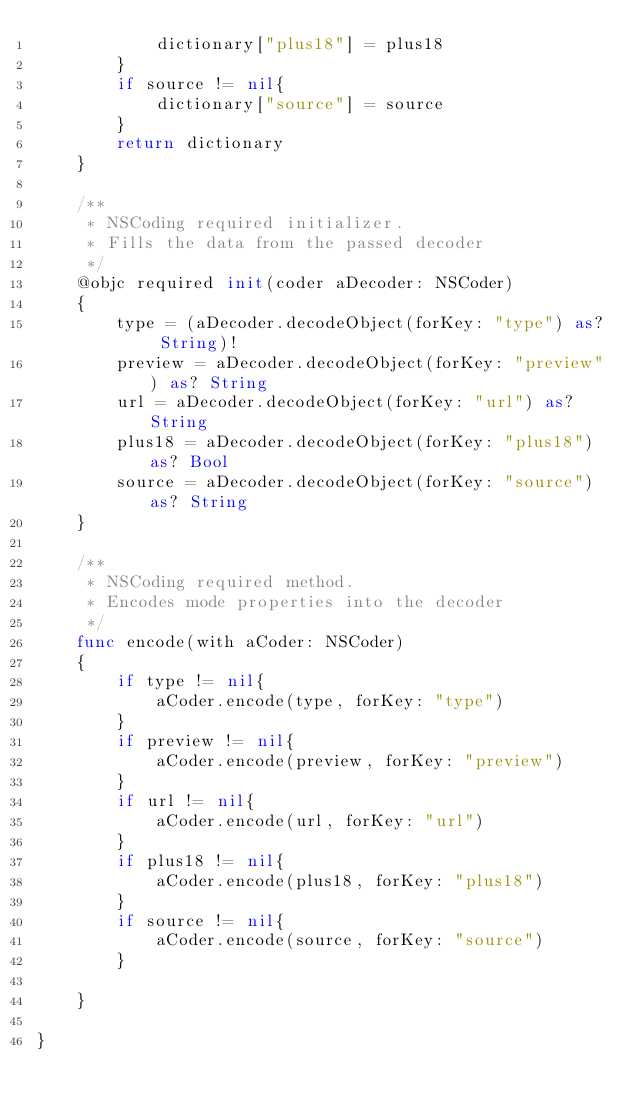Convert code to text. <code><loc_0><loc_0><loc_500><loc_500><_Swift_>            dictionary["plus18"] = plus18
        }
        if source != nil{
            dictionary["source"] = source
        }
        return dictionary
    }
    
    /**
     * NSCoding required initializer.
     * Fills the data from the passed decoder
     */
    @objc required init(coder aDecoder: NSCoder)
    {
        type = (aDecoder.decodeObject(forKey: "type") as? String)!
        preview = aDecoder.decodeObject(forKey: "preview") as? String
        url = aDecoder.decodeObject(forKey: "url") as? String
        plus18 = aDecoder.decodeObject(forKey: "plus18") as? Bool
        source = aDecoder.decodeObject(forKey: "source") as? String
    }
    
    /**
     * NSCoding required method.
     * Encodes mode properties into the decoder
     */
    func encode(with aCoder: NSCoder)
    {
        if type != nil{
            aCoder.encode(type, forKey: "type")
        }
        if preview != nil{
            aCoder.encode(preview, forKey: "preview")
        }
        if url != nil{
            aCoder.encode(url, forKey: "url")
        }
        if plus18 != nil{
            aCoder.encode(plus18, forKey: "plus18")
        }
        if source != nil{
            aCoder.encode(source, forKey: "source")
        }
        
    }
    
}
</code> 